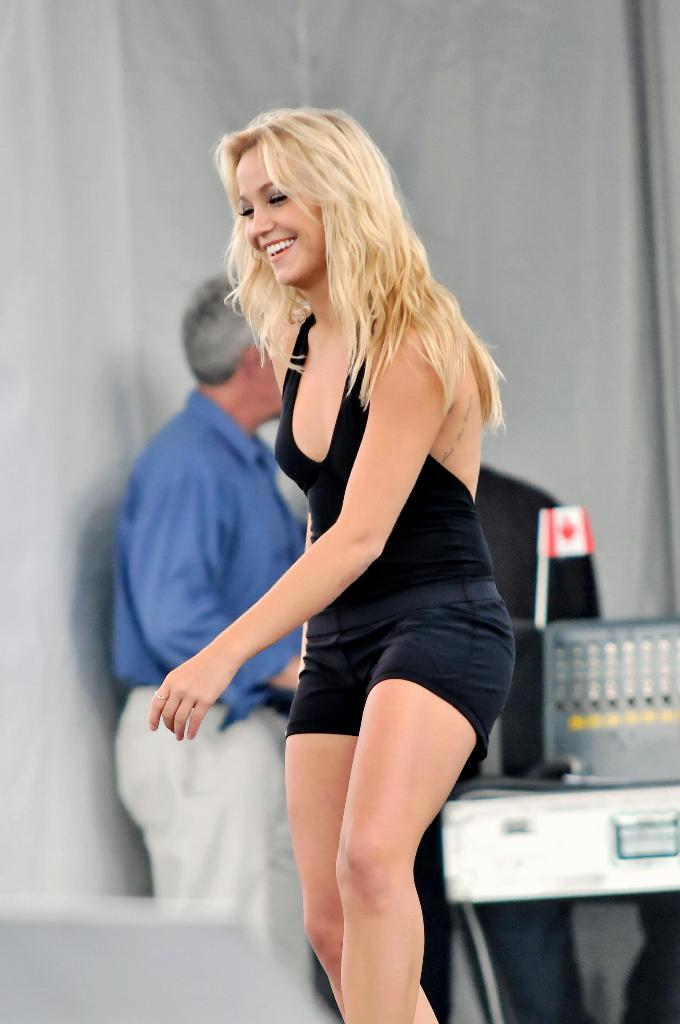Who is present in the image? There is a woman in the image. What is the woman doing? The woman is smiling. What can be seen in the background of the image? There are curtains in the background of the image. How many people are standing in the image? There are two people standing in the image. What else is visible in the image besides the people? There is a flag and devices visible in the image. What type of stew is being prepared by the bears in the image? There are no bears present in the image, so it is not possible to determine if any stew is being prepared. 